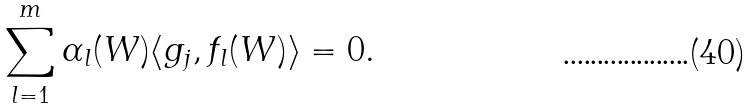Convert formula to latex. <formula><loc_0><loc_0><loc_500><loc_500>\sum _ { l = 1 } ^ { m } \alpha _ { l } ( W ) \langle g _ { j } , f _ { l } ( W ) \rangle = 0 .</formula> 